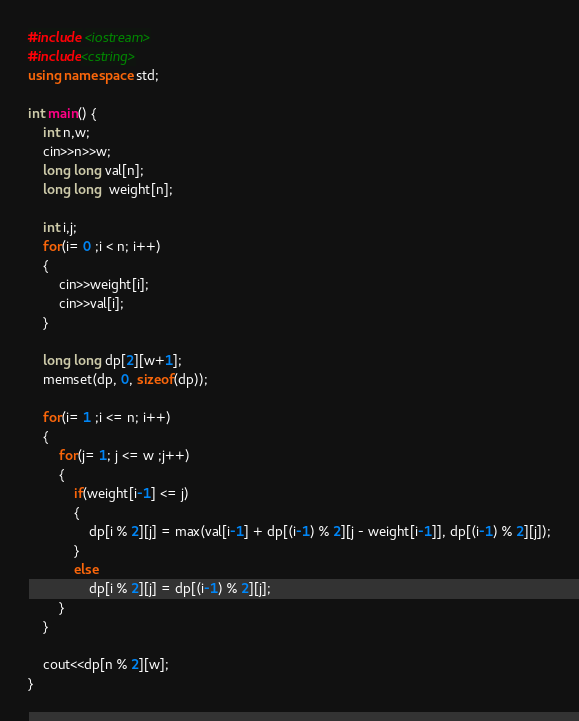Convert code to text. <code><loc_0><loc_0><loc_500><loc_500><_C++_>#include <iostream>
#include<cstring>
using namespace std;

int main() {
    int n,w;
    cin>>n>>w;
    long long val[n];
    long long  weight[n];
    
    int i,j;
    for(i= 0 ;i < n; i++)
    {
        cin>>weight[i];
        cin>>val[i];
    }
    
    long long dp[2][w+1];
    memset(dp, 0, sizeof(dp));
    
    for(i= 1 ;i <= n; i++)
    {
        for(j= 1; j <= w ;j++)
        {
            if(weight[i-1] <= j)
            {
                dp[i % 2][j] = max(val[i-1] + dp[(i-1) % 2][j - weight[i-1]], dp[(i-1) % 2][j]);
            }
            else
                dp[i % 2][j] = dp[(i-1) % 2][j];
        }
    }

    cout<<dp[n % 2][w];
}</code> 